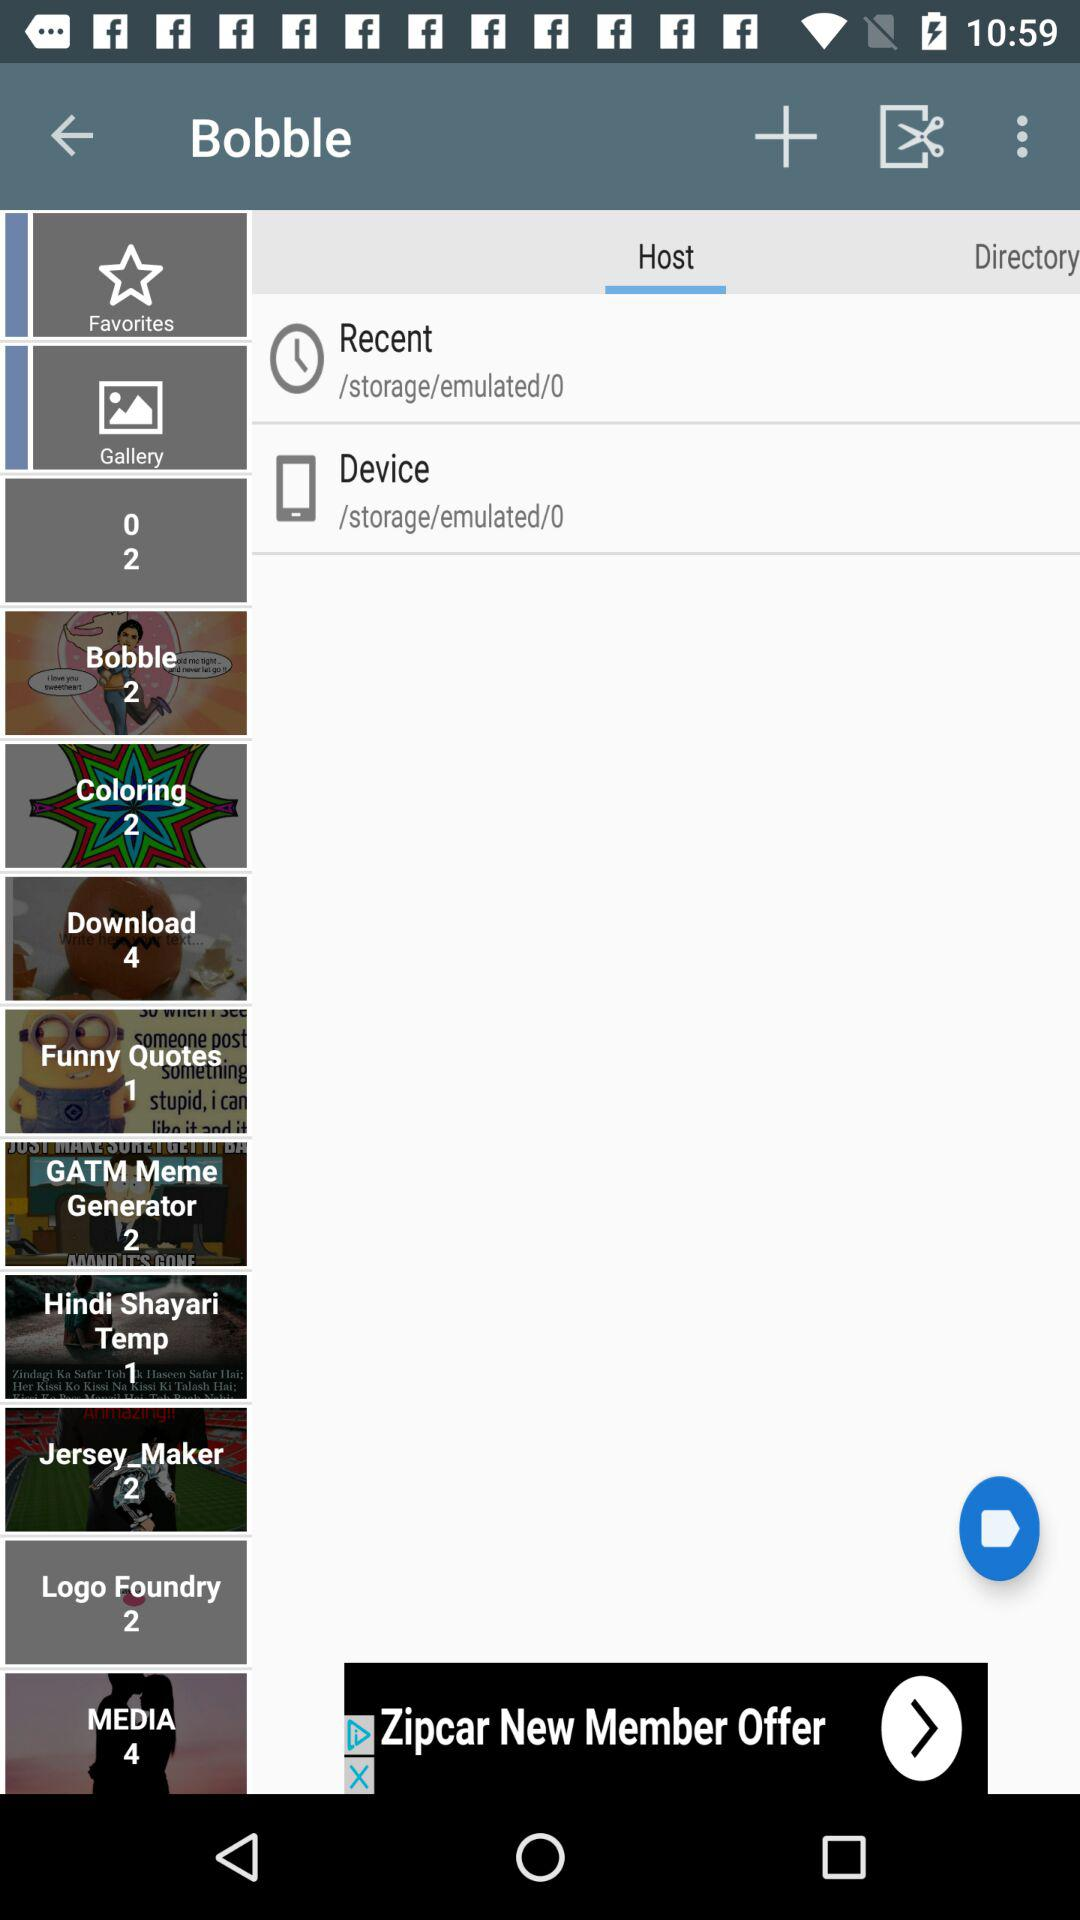What tab is selected? The selected tab is "Host". 